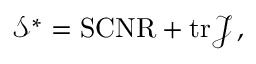<formula> <loc_0><loc_0><loc_500><loc_500>\begin{array} { r } { \mathcal { S } ^ { * } = S C N R + t r \mathcal { J } \, , } \end{array}</formula> 